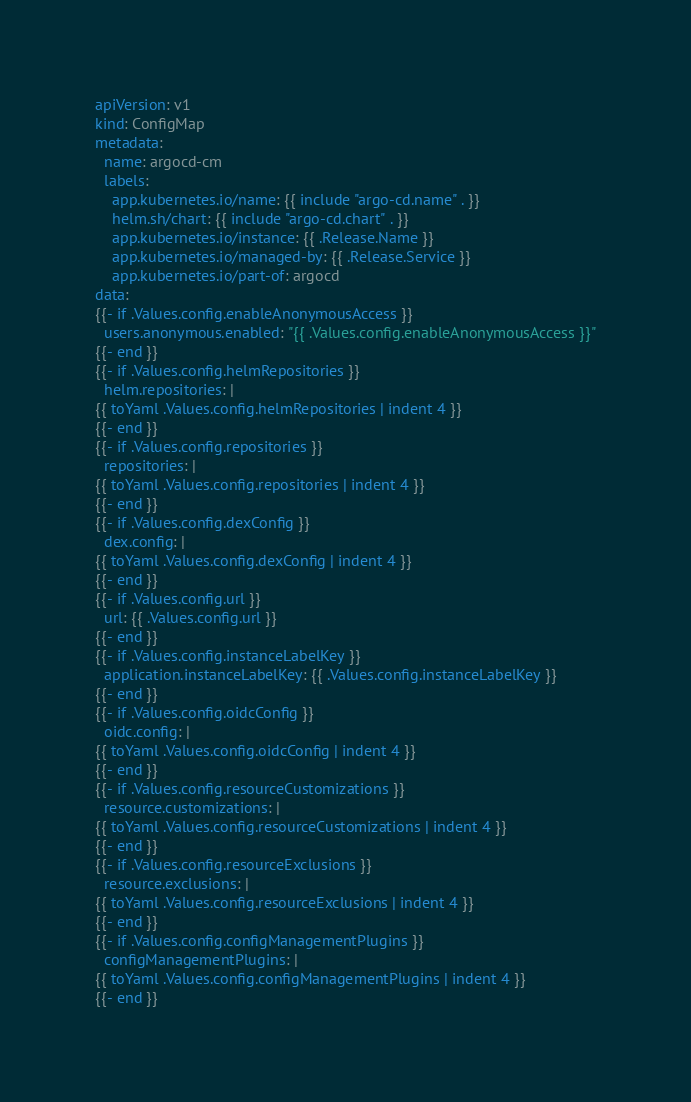<code> <loc_0><loc_0><loc_500><loc_500><_YAML_>apiVersion: v1
kind: ConfigMap
metadata:
  name: argocd-cm
  labels:
    app.kubernetes.io/name: {{ include "argo-cd.name" . }}
    helm.sh/chart: {{ include "argo-cd.chart" . }}
    app.kubernetes.io/instance: {{ .Release.Name }}
    app.kubernetes.io/managed-by: {{ .Release.Service }}
    app.kubernetes.io/part-of: argocd
data:
{{- if .Values.config.enableAnonymousAccess }}
  users.anonymous.enabled: "{{ .Values.config.enableAnonymousAccess }}"
{{- end }}
{{- if .Values.config.helmRepositories }}
  helm.repositories: |
{{ toYaml .Values.config.helmRepositories | indent 4 }}
{{- end }}
{{- if .Values.config.repositories }}
  repositories: |
{{ toYaml .Values.config.repositories | indent 4 }}
{{- end }}
{{- if .Values.config.dexConfig }}
  dex.config: |
{{ toYaml .Values.config.dexConfig | indent 4 }}
{{- end }}
{{- if .Values.config.url }}
  url: {{ .Values.config.url }}
{{- end }}
{{- if .Values.config.instanceLabelKey }}
  application.instanceLabelKey: {{ .Values.config.instanceLabelKey }}
{{- end }}
{{- if .Values.config.oidcConfig }}
  oidc.config: |
{{ toYaml .Values.config.oidcConfig | indent 4 }}
{{- end }}
{{- if .Values.config.resourceCustomizations }}
  resource.customizations: |
{{ toYaml .Values.config.resourceCustomizations | indent 4 }}
{{- end }}
{{- if .Values.config.resourceExclusions }}
  resource.exclusions: |
{{ toYaml .Values.config.resourceExclusions | indent 4 }}
{{- end }}
{{- if .Values.config.configManagementPlugins }}
  configManagementPlugins: |
{{ toYaml .Values.config.configManagementPlugins | indent 4 }}
{{- end }}
</code> 